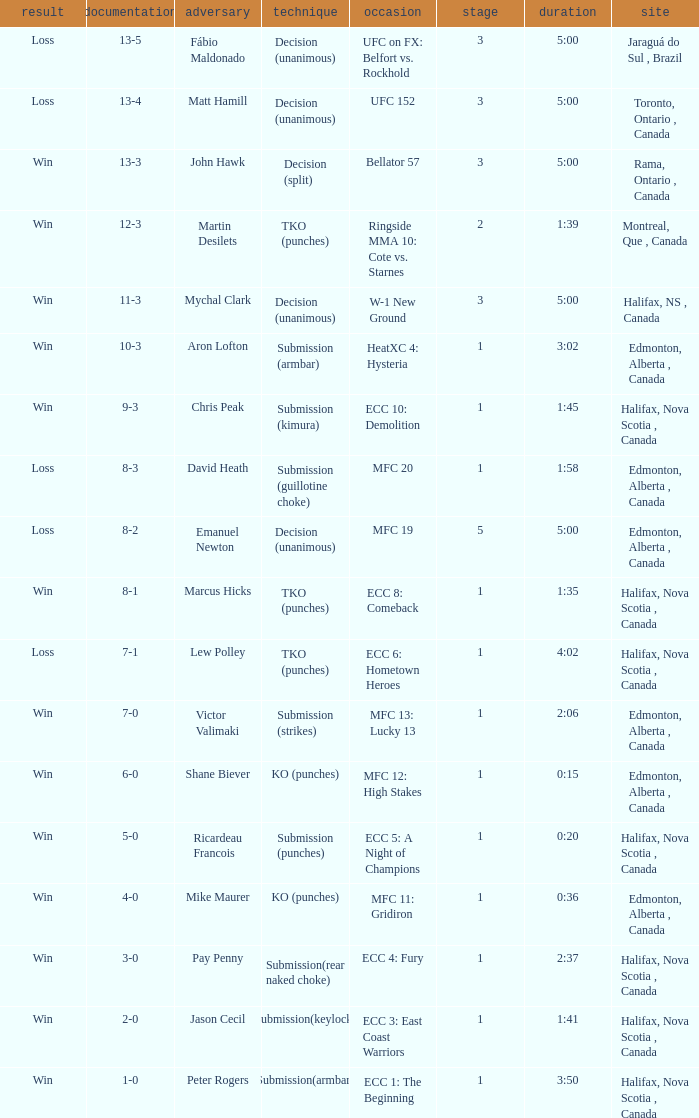What is the location of the match with Aron Lofton as the opponent? Edmonton, Alberta , Canada. 